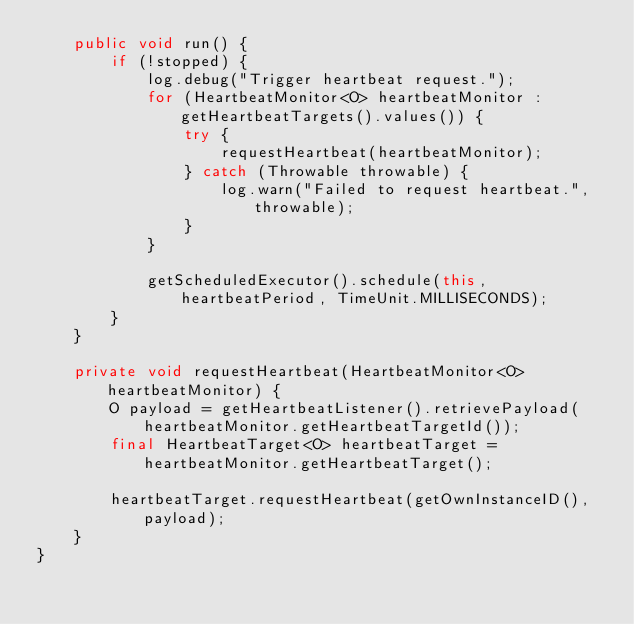Convert code to text. <code><loc_0><loc_0><loc_500><loc_500><_Java_>    public void run() {
        if (!stopped) {
            log.debug("Trigger heartbeat request.");
            for (HeartbeatMonitor<O> heartbeatMonitor : getHeartbeatTargets().values()) {
                try {
                    requestHeartbeat(heartbeatMonitor);
                } catch (Throwable throwable) {
                    log.warn("Failed to request heartbeat.", throwable);
                }
            }

            getScheduledExecutor().schedule(this, heartbeatPeriod, TimeUnit.MILLISECONDS);
        }
    }

    private void requestHeartbeat(HeartbeatMonitor<O> heartbeatMonitor) {
        O payload = getHeartbeatListener().retrievePayload(heartbeatMonitor.getHeartbeatTargetId());
        final HeartbeatTarget<O> heartbeatTarget = heartbeatMonitor.getHeartbeatTarget();

        heartbeatTarget.requestHeartbeat(getOwnInstanceID(), payload);
    }
}
</code> 